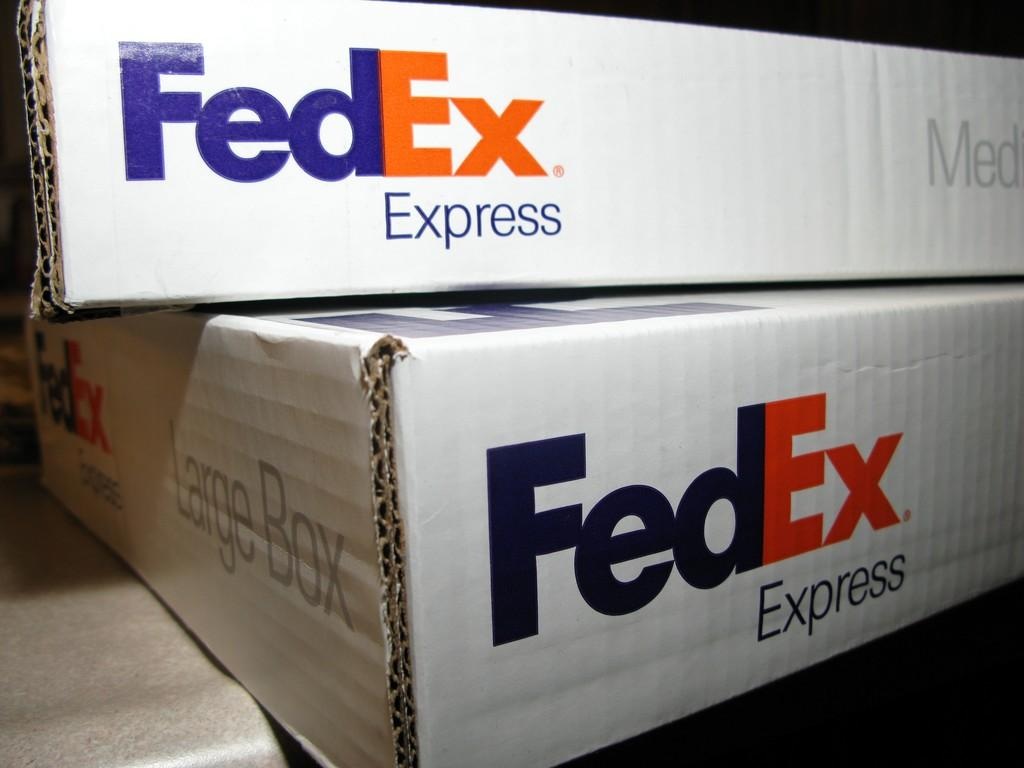Provide a one-sentence caption for the provided image. A medium FedEx Express box can stack on top of a large FedEx Express box. 